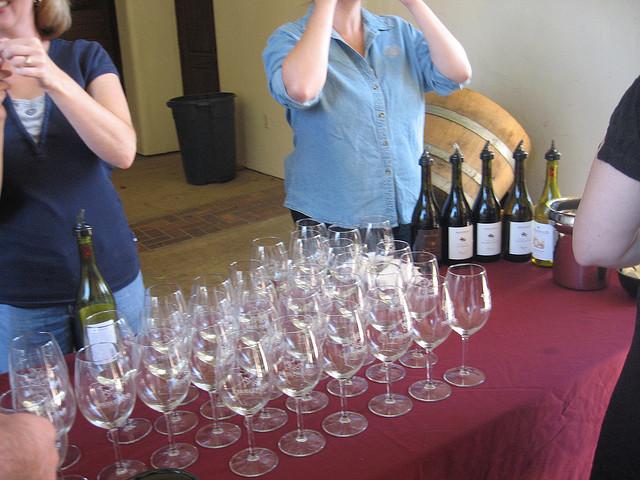Does the person in the middle have a denim shirt?
Quick response, please. Yes. What color is the tablecloth?
Keep it brief. Red. What are the people drinking?
Keep it brief. Wine. 